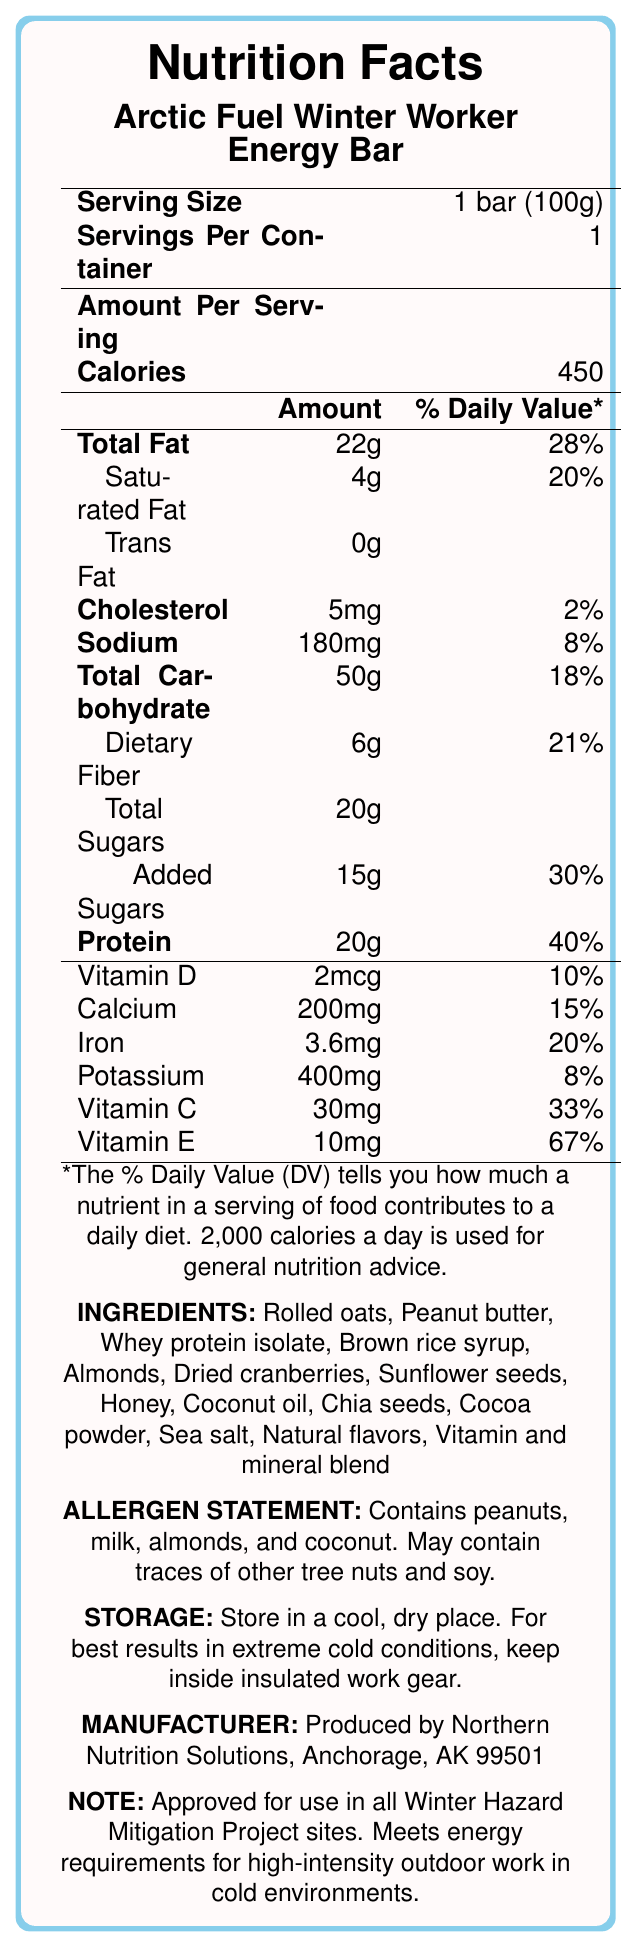what is the serving size of the Arctic Fuel Winter Worker Energy Bar? The serving size is explicitly mentioned as "1 bar (100g)" in the Nutrition Facts section of the document.
Answer: 1 bar (100g) How many grams of total fat does one bar contain? The document states that one bar contains 22 grams of total fat.
Answer: 22g What is the percentage of the daily value for protein in one serving? The document indicates that one serving provides 40% of the daily value for protein.
Answer: 40% List three primary ingredients in the Arctic Fuel Winter Worker Energy Bar. The ingredients list shows that rolled oats, peanut butter, and whey protein isolate are among the primary ingredients.
Answer: Rolled oats, Peanut butter, Whey protein isolate what is the allergen statement of the Arctic Fuel Winter Worker Energy Bar? The document's allergen statement mentions these allergens and possible traces.
Answer: Contains peanuts, milk, almonds, and coconut. May contain traces of other tree nuts and soy. which vitamin has the highest percentage of daily value in the energy bar? A. Vitamin D B. Vitamin C C. Vitamin E D. Calcium Vitamin E has the highest percentage of daily value at 67%.
Answer: C How much dietary fiber is in each serving? A. 3g B. 5g C. 6g D. 8g The dietary fiber amount per serving is listed as 6g in the document.
Answer: C Is this product approved for use in Winter Hazard Mitigation Project sites? The project-specific note clearly states that the product is approved for use at Winter Hazard Mitigation Project sites.
Answer: Yes What manufacturers are behind the Arctic Fuel Winter Worker Energy Bar? The manufacturer information is provided at the end of the document.
Answer: Northern Nutrition Solutions, Anchorage, AK 99501 Summarize the main idea of the document. The document contains comprehensive information about the nutrient content, ingredients, possible allergens, storage, and manufacturer details, emphasizing that the energy bar meets the energy needs for high-intensity outdoor work in winter conditions.
Answer: The Nutrition Facts Label for the Arctic Fuel Winter Worker Energy Bar provides detailed nutritional information, ingredient list, allergen statement, storage instructions, manufacturer info, and a note indicating approval for Winter Hazard Mitigation Project sites. which ingredient is not listed in the document? The document does not list every possible ingredient; it only lists specific ones, and without further information, we cannot determine all ingredients.
Answer: I don't know What is the storage instruction for the energy bar in extreme cold conditions? The storage instruction for extreme cold conditions suggests keeping the bar inside insulated work gear for best results.
Answer: Keep inside insulated work gear. 